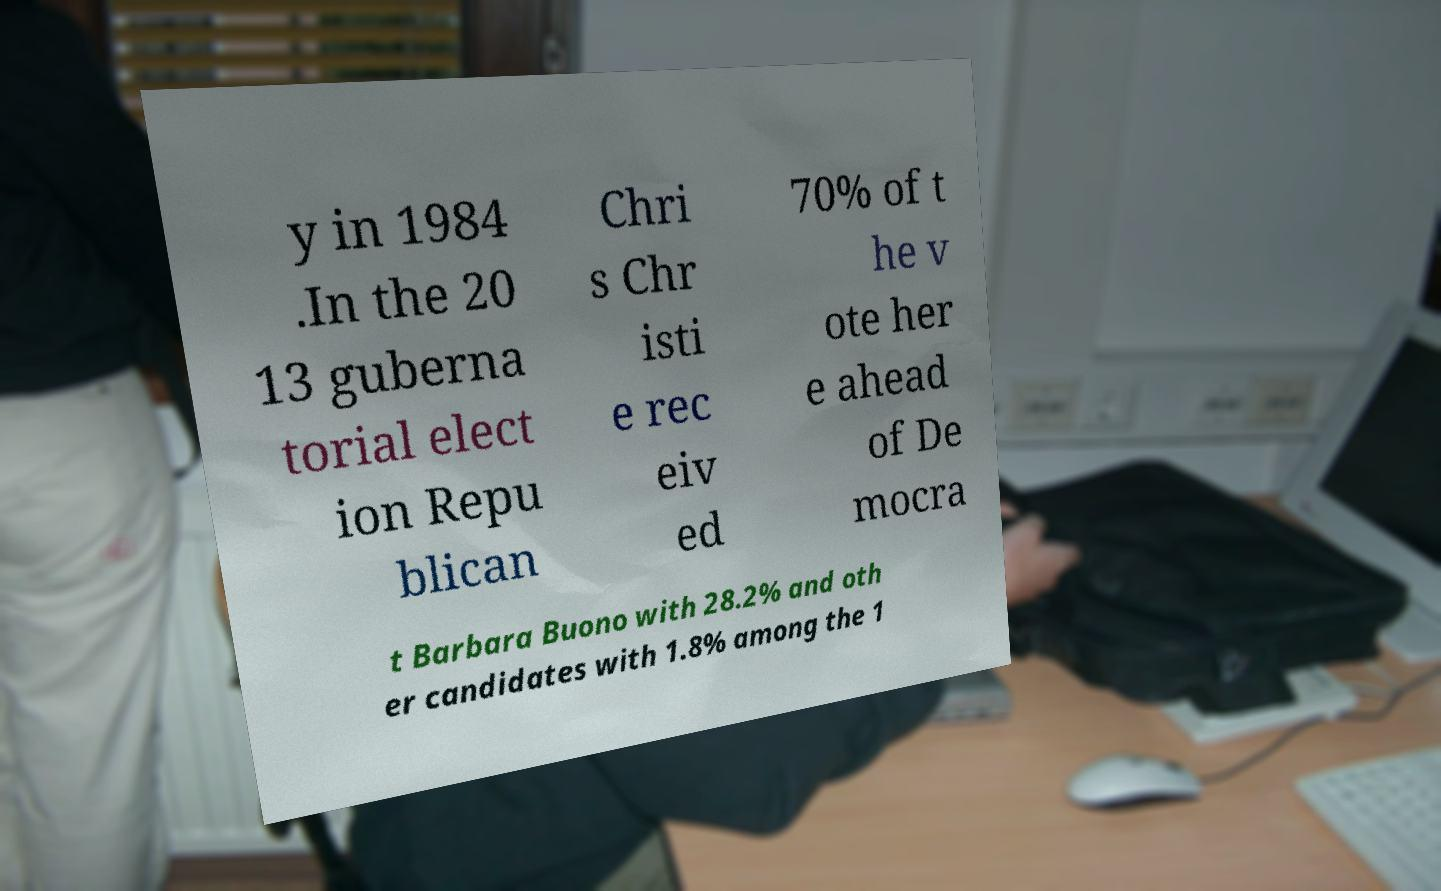I need the written content from this picture converted into text. Can you do that? y in 1984 .In the 20 13 guberna torial elect ion Repu blican Chri s Chr isti e rec eiv ed 70% of t he v ote her e ahead of De mocra t Barbara Buono with 28.2% and oth er candidates with 1.8% among the 1 